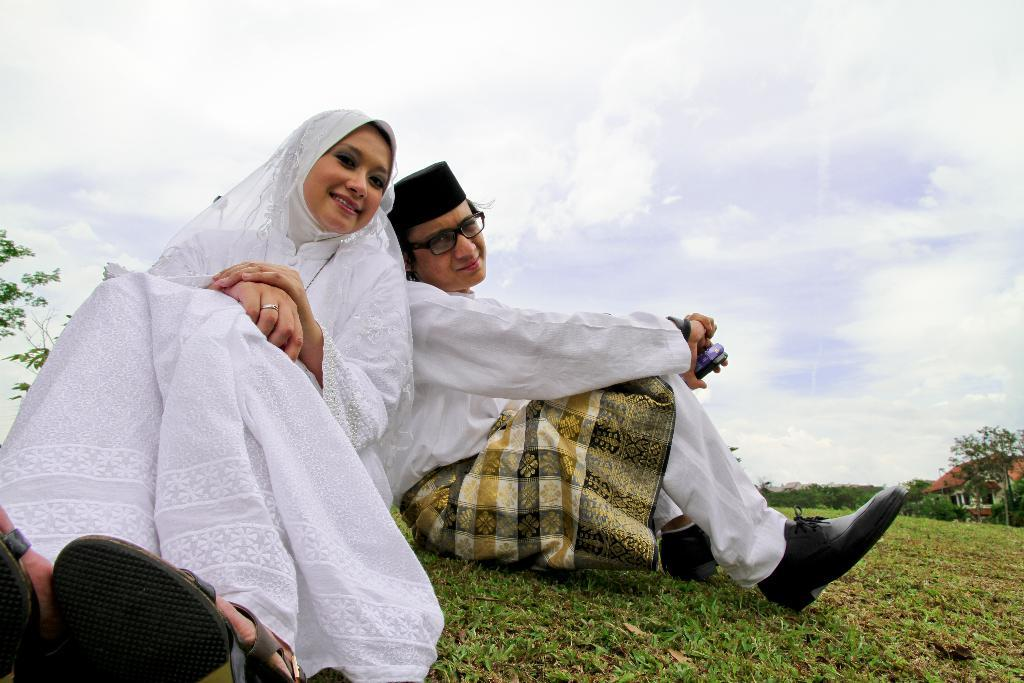How many people are in the image? There are two persons in the image. What are the persons doing in the image? The persons are smiling. Where are the persons sitting in the image? The persons are sitting on the grass. What can be seen in the background of the image? There is a house, trees, and the sky visible in the background of the image. How many kittens are playing with the cakes in the image? There are no kittens or cakes present in the image. What type of duck can be seen swimming in the background of the image? There is no duck visible in the image; only a house, trees, and the sky can be seen in the background. 